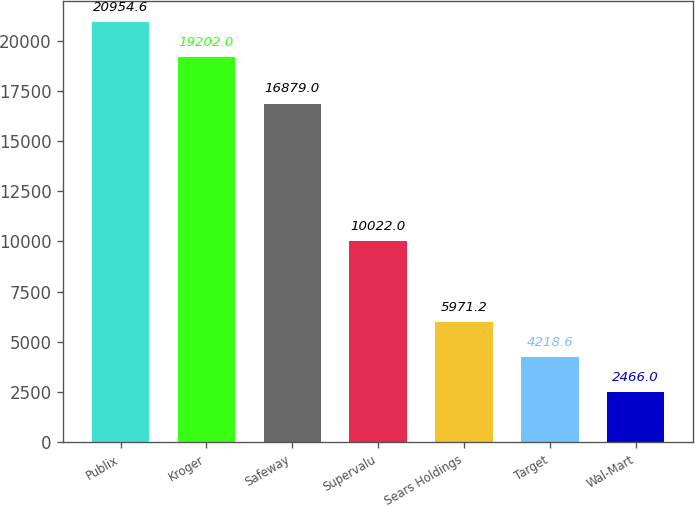<chart> <loc_0><loc_0><loc_500><loc_500><bar_chart><fcel>Publix<fcel>Kroger<fcel>Safeway<fcel>Supervalu<fcel>Sears Holdings<fcel>Target<fcel>Wal-Mart<nl><fcel>20954.6<fcel>19202<fcel>16879<fcel>10022<fcel>5971.2<fcel>4218.6<fcel>2466<nl></chart> 